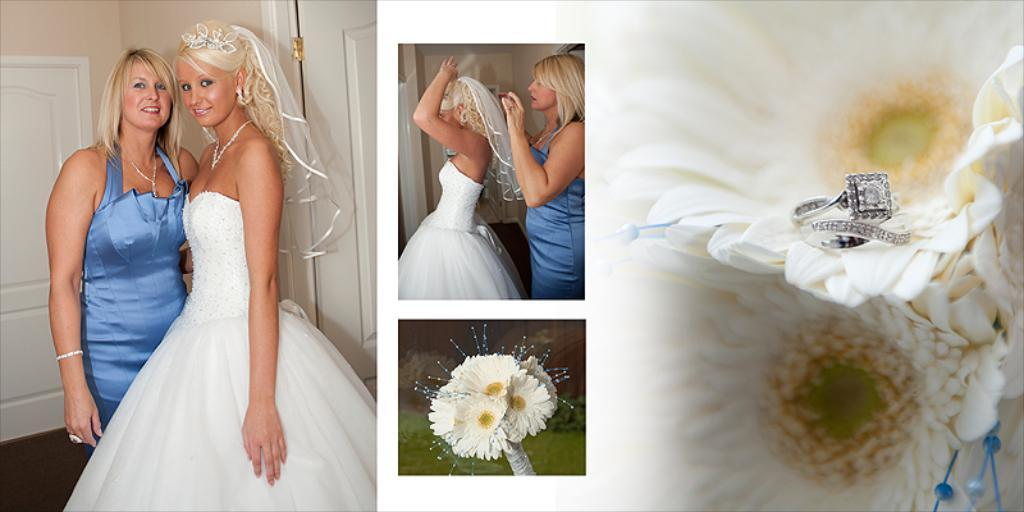What type of artwork is depicted in the image? The image is a collage. Can you describe the subjects in the image? There are people and flowers in the image. What architectural features can be seen in the image? There are doors and a wall in the image. Is there any additional detail on the flowers in the image? Yes, there is a ring on one of the flowers. What type of berry can be seen growing on the bushes in the image? There are no bushes or berries present in the image; it features a collage with people, flowers, doors, and a wall. Are there any beds visible in the image? There are no beds present in the image. 